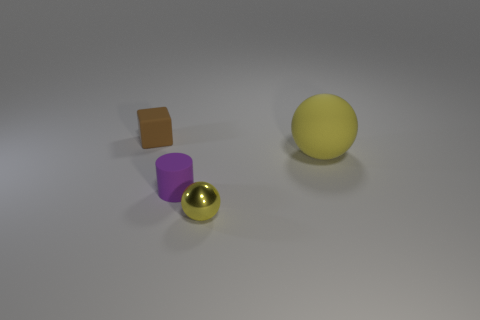Add 2 large yellow objects. How many objects exist? 6 Subtract all cylinders. How many objects are left? 3 Add 1 yellow rubber spheres. How many yellow rubber spheres are left? 2 Add 2 spheres. How many spheres exist? 4 Subtract 1 purple cylinders. How many objects are left? 3 Subtract all tiny yellow shiny things. Subtract all small metal spheres. How many objects are left? 2 